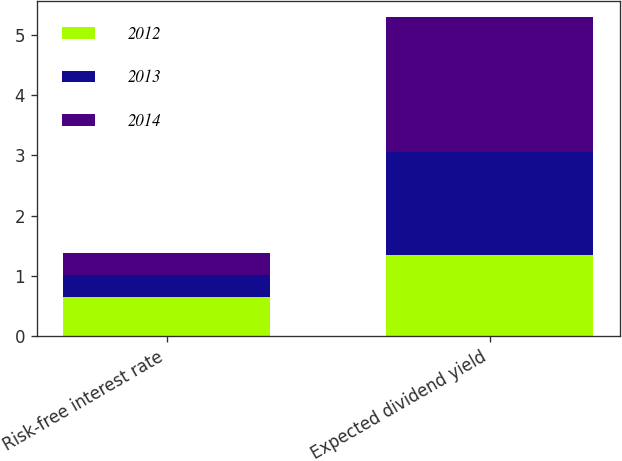<chart> <loc_0><loc_0><loc_500><loc_500><stacked_bar_chart><ecel><fcel>Risk-free interest rate<fcel>Expected dividend yield<nl><fcel>2012<fcel>0.65<fcel>1.34<nl><fcel>2013<fcel>0.36<fcel>1.71<nl><fcel>2014<fcel>0.37<fcel>2.24<nl></chart> 